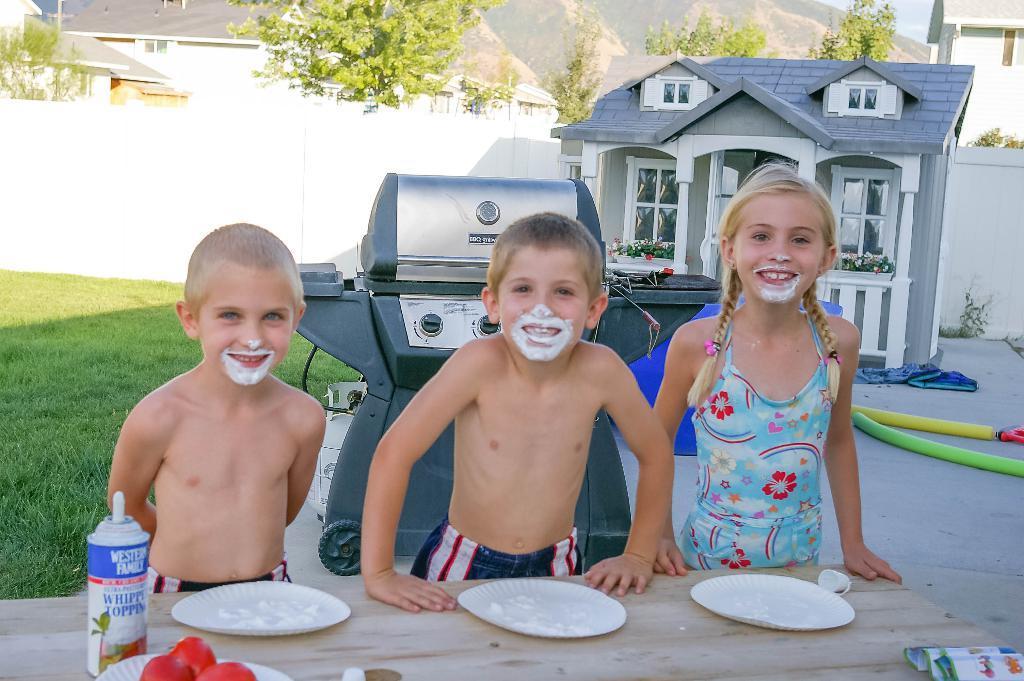Can you describe this image briefly? Here we can see the children are standing and smiling, and in front here is the table and plates and some objects on it, and here is the grass, and here is the building, and here are the mountains, and here is the tree. 